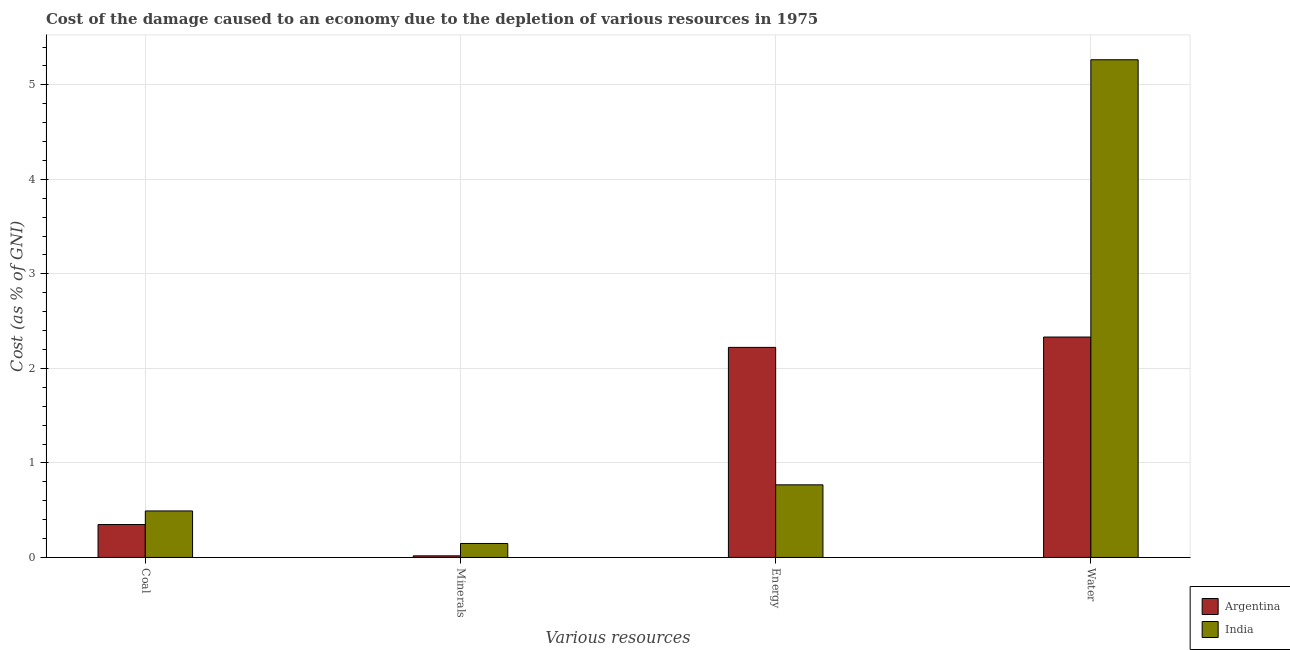How many different coloured bars are there?
Make the answer very short. 2. How many bars are there on the 4th tick from the left?
Your answer should be compact. 2. How many bars are there on the 1st tick from the right?
Ensure brevity in your answer.  2. What is the label of the 2nd group of bars from the left?
Keep it short and to the point. Minerals. What is the cost of damage due to depletion of energy in Argentina?
Your answer should be very brief. 2.22. Across all countries, what is the maximum cost of damage due to depletion of energy?
Give a very brief answer. 2.22. Across all countries, what is the minimum cost of damage due to depletion of minerals?
Offer a terse response. 0.02. What is the total cost of damage due to depletion of coal in the graph?
Make the answer very short. 0.84. What is the difference between the cost of damage due to depletion of water in India and that in Argentina?
Your response must be concise. 2.93. What is the difference between the cost of damage due to depletion of energy in Argentina and the cost of damage due to depletion of minerals in India?
Your answer should be very brief. 2.07. What is the average cost of damage due to depletion of water per country?
Keep it short and to the point. 3.8. What is the difference between the cost of damage due to depletion of water and cost of damage due to depletion of minerals in India?
Give a very brief answer. 5.12. In how many countries, is the cost of damage due to depletion of coal greater than 2.6 %?
Provide a short and direct response. 0. What is the ratio of the cost of damage due to depletion of minerals in Argentina to that in India?
Offer a very short reply. 0.11. What is the difference between the highest and the second highest cost of damage due to depletion of water?
Your answer should be compact. 2.93. What is the difference between the highest and the lowest cost of damage due to depletion of energy?
Your response must be concise. 1.45. What does the 2nd bar from the right in Coal represents?
Keep it short and to the point. Argentina. Is it the case that in every country, the sum of the cost of damage due to depletion of coal and cost of damage due to depletion of minerals is greater than the cost of damage due to depletion of energy?
Keep it short and to the point. No. How many countries are there in the graph?
Your response must be concise. 2. What is the difference between two consecutive major ticks on the Y-axis?
Your answer should be compact. 1. Does the graph contain grids?
Ensure brevity in your answer.  Yes. How are the legend labels stacked?
Your answer should be very brief. Vertical. What is the title of the graph?
Provide a succinct answer. Cost of the damage caused to an economy due to the depletion of various resources in 1975 . Does "Seychelles" appear as one of the legend labels in the graph?
Your response must be concise. No. What is the label or title of the X-axis?
Your response must be concise. Various resources. What is the label or title of the Y-axis?
Give a very brief answer. Cost (as % of GNI). What is the Cost (as % of GNI) in Argentina in Coal?
Your answer should be very brief. 0.35. What is the Cost (as % of GNI) of India in Coal?
Make the answer very short. 0.49. What is the Cost (as % of GNI) of Argentina in Minerals?
Ensure brevity in your answer.  0.02. What is the Cost (as % of GNI) in India in Minerals?
Your answer should be very brief. 0.15. What is the Cost (as % of GNI) in Argentina in Energy?
Keep it short and to the point. 2.22. What is the Cost (as % of GNI) in India in Energy?
Offer a very short reply. 0.77. What is the Cost (as % of GNI) in Argentina in Water?
Provide a short and direct response. 2.33. What is the Cost (as % of GNI) of India in Water?
Provide a succinct answer. 5.27. Across all Various resources, what is the maximum Cost (as % of GNI) in Argentina?
Keep it short and to the point. 2.33. Across all Various resources, what is the maximum Cost (as % of GNI) of India?
Give a very brief answer. 5.27. Across all Various resources, what is the minimum Cost (as % of GNI) in Argentina?
Offer a very short reply. 0.02. Across all Various resources, what is the minimum Cost (as % of GNI) in India?
Offer a very short reply. 0.15. What is the total Cost (as % of GNI) of Argentina in the graph?
Offer a very short reply. 4.92. What is the total Cost (as % of GNI) in India in the graph?
Give a very brief answer. 6.67. What is the difference between the Cost (as % of GNI) in Argentina in Coal and that in Minerals?
Your answer should be very brief. 0.33. What is the difference between the Cost (as % of GNI) of India in Coal and that in Minerals?
Provide a short and direct response. 0.34. What is the difference between the Cost (as % of GNI) in Argentina in Coal and that in Energy?
Your answer should be compact. -1.87. What is the difference between the Cost (as % of GNI) in India in Coal and that in Energy?
Offer a terse response. -0.28. What is the difference between the Cost (as % of GNI) in Argentina in Coal and that in Water?
Offer a terse response. -1.98. What is the difference between the Cost (as % of GNI) in India in Coal and that in Water?
Offer a terse response. -4.77. What is the difference between the Cost (as % of GNI) of Argentina in Minerals and that in Energy?
Offer a terse response. -2.21. What is the difference between the Cost (as % of GNI) of India in Minerals and that in Energy?
Make the answer very short. -0.62. What is the difference between the Cost (as % of GNI) of Argentina in Minerals and that in Water?
Provide a short and direct response. -2.31. What is the difference between the Cost (as % of GNI) in India in Minerals and that in Water?
Your answer should be compact. -5.12. What is the difference between the Cost (as % of GNI) of Argentina in Energy and that in Water?
Your answer should be compact. -0.11. What is the difference between the Cost (as % of GNI) in India in Energy and that in Water?
Your answer should be compact. -4.5. What is the difference between the Cost (as % of GNI) in Argentina in Coal and the Cost (as % of GNI) in India in Minerals?
Provide a succinct answer. 0.2. What is the difference between the Cost (as % of GNI) of Argentina in Coal and the Cost (as % of GNI) of India in Energy?
Your answer should be compact. -0.42. What is the difference between the Cost (as % of GNI) in Argentina in Coal and the Cost (as % of GNI) in India in Water?
Offer a terse response. -4.92. What is the difference between the Cost (as % of GNI) of Argentina in Minerals and the Cost (as % of GNI) of India in Energy?
Provide a succinct answer. -0.75. What is the difference between the Cost (as % of GNI) of Argentina in Minerals and the Cost (as % of GNI) of India in Water?
Ensure brevity in your answer.  -5.25. What is the difference between the Cost (as % of GNI) in Argentina in Energy and the Cost (as % of GNI) in India in Water?
Offer a very short reply. -3.04. What is the average Cost (as % of GNI) of Argentina per Various resources?
Offer a very short reply. 1.23. What is the average Cost (as % of GNI) in India per Various resources?
Offer a terse response. 1.67. What is the difference between the Cost (as % of GNI) of Argentina and Cost (as % of GNI) of India in Coal?
Make the answer very short. -0.14. What is the difference between the Cost (as % of GNI) in Argentina and Cost (as % of GNI) in India in Minerals?
Offer a very short reply. -0.13. What is the difference between the Cost (as % of GNI) of Argentina and Cost (as % of GNI) of India in Energy?
Your answer should be very brief. 1.45. What is the difference between the Cost (as % of GNI) in Argentina and Cost (as % of GNI) in India in Water?
Your answer should be compact. -2.93. What is the ratio of the Cost (as % of GNI) of Argentina in Coal to that in Minerals?
Ensure brevity in your answer.  20.69. What is the ratio of the Cost (as % of GNI) of India in Coal to that in Minerals?
Your answer should be compact. 3.33. What is the ratio of the Cost (as % of GNI) of Argentina in Coal to that in Energy?
Provide a succinct answer. 0.16. What is the ratio of the Cost (as % of GNI) in India in Coal to that in Energy?
Ensure brevity in your answer.  0.64. What is the ratio of the Cost (as % of GNI) in Argentina in Coal to that in Water?
Your response must be concise. 0.15. What is the ratio of the Cost (as % of GNI) in India in Coal to that in Water?
Keep it short and to the point. 0.09. What is the ratio of the Cost (as % of GNI) of Argentina in Minerals to that in Energy?
Your answer should be very brief. 0.01. What is the ratio of the Cost (as % of GNI) of India in Minerals to that in Energy?
Provide a succinct answer. 0.19. What is the ratio of the Cost (as % of GNI) in Argentina in Minerals to that in Water?
Your response must be concise. 0.01. What is the ratio of the Cost (as % of GNI) in India in Minerals to that in Water?
Offer a very short reply. 0.03. What is the ratio of the Cost (as % of GNI) in Argentina in Energy to that in Water?
Give a very brief answer. 0.95. What is the ratio of the Cost (as % of GNI) of India in Energy to that in Water?
Keep it short and to the point. 0.15. What is the difference between the highest and the second highest Cost (as % of GNI) in Argentina?
Keep it short and to the point. 0.11. What is the difference between the highest and the second highest Cost (as % of GNI) of India?
Your response must be concise. 4.5. What is the difference between the highest and the lowest Cost (as % of GNI) in Argentina?
Your answer should be compact. 2.31. What is the difference between the highest and the lowest Cost (as % of GNI) in India?
Provide a short and direct response. 5.12. 